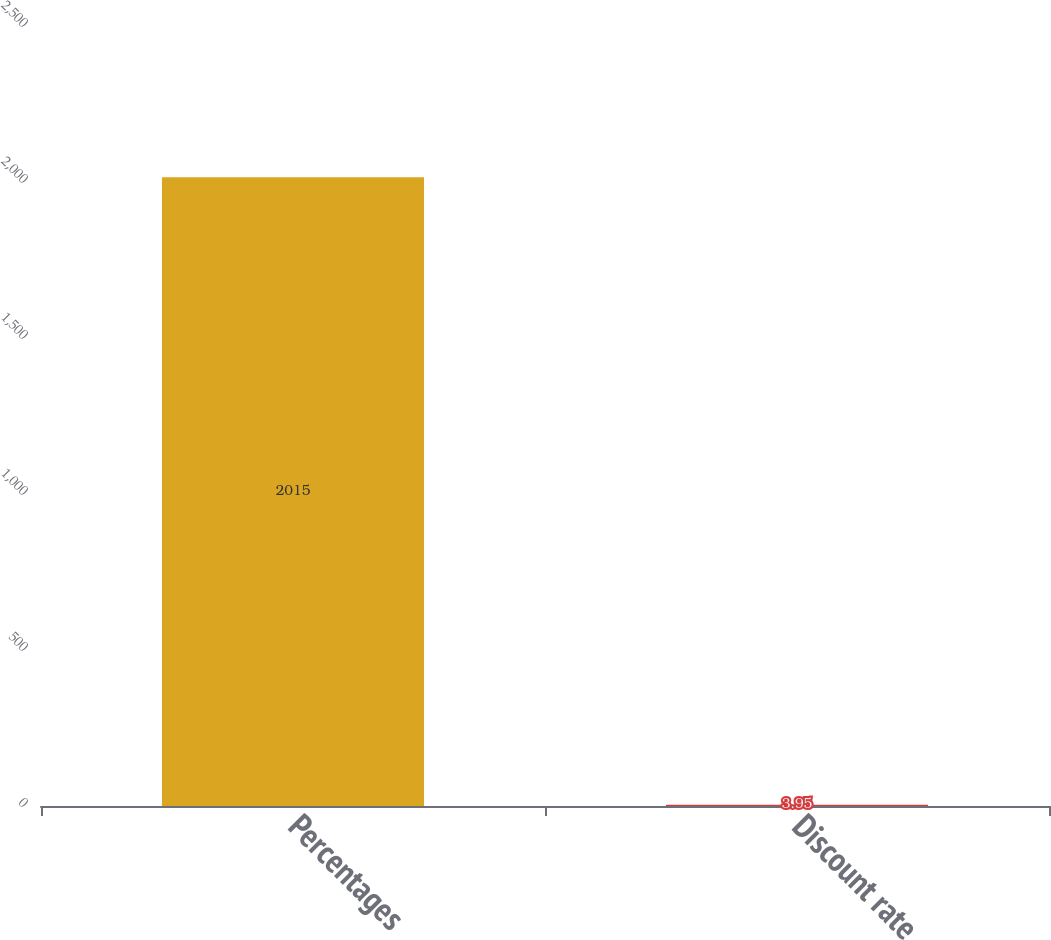Convert chart. <chart><loc_0><loc_0><loc_500><loc_500><bar_chart><fcel>Percentages<fcel>Discount rate<nl><fcel>2015<fcel>3.95<nl></chart> 